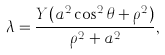Convert formula to latex. <formula><loc_0><loc_0><loc_500><loc_500>\lambda = \frac { Y ( a ^ { 2 } \cos ^ { 2 } \theta + \rho ^ { 2 } ) } { \rho ^ { 2 } + a ^ { 2 } } ,</formula> 